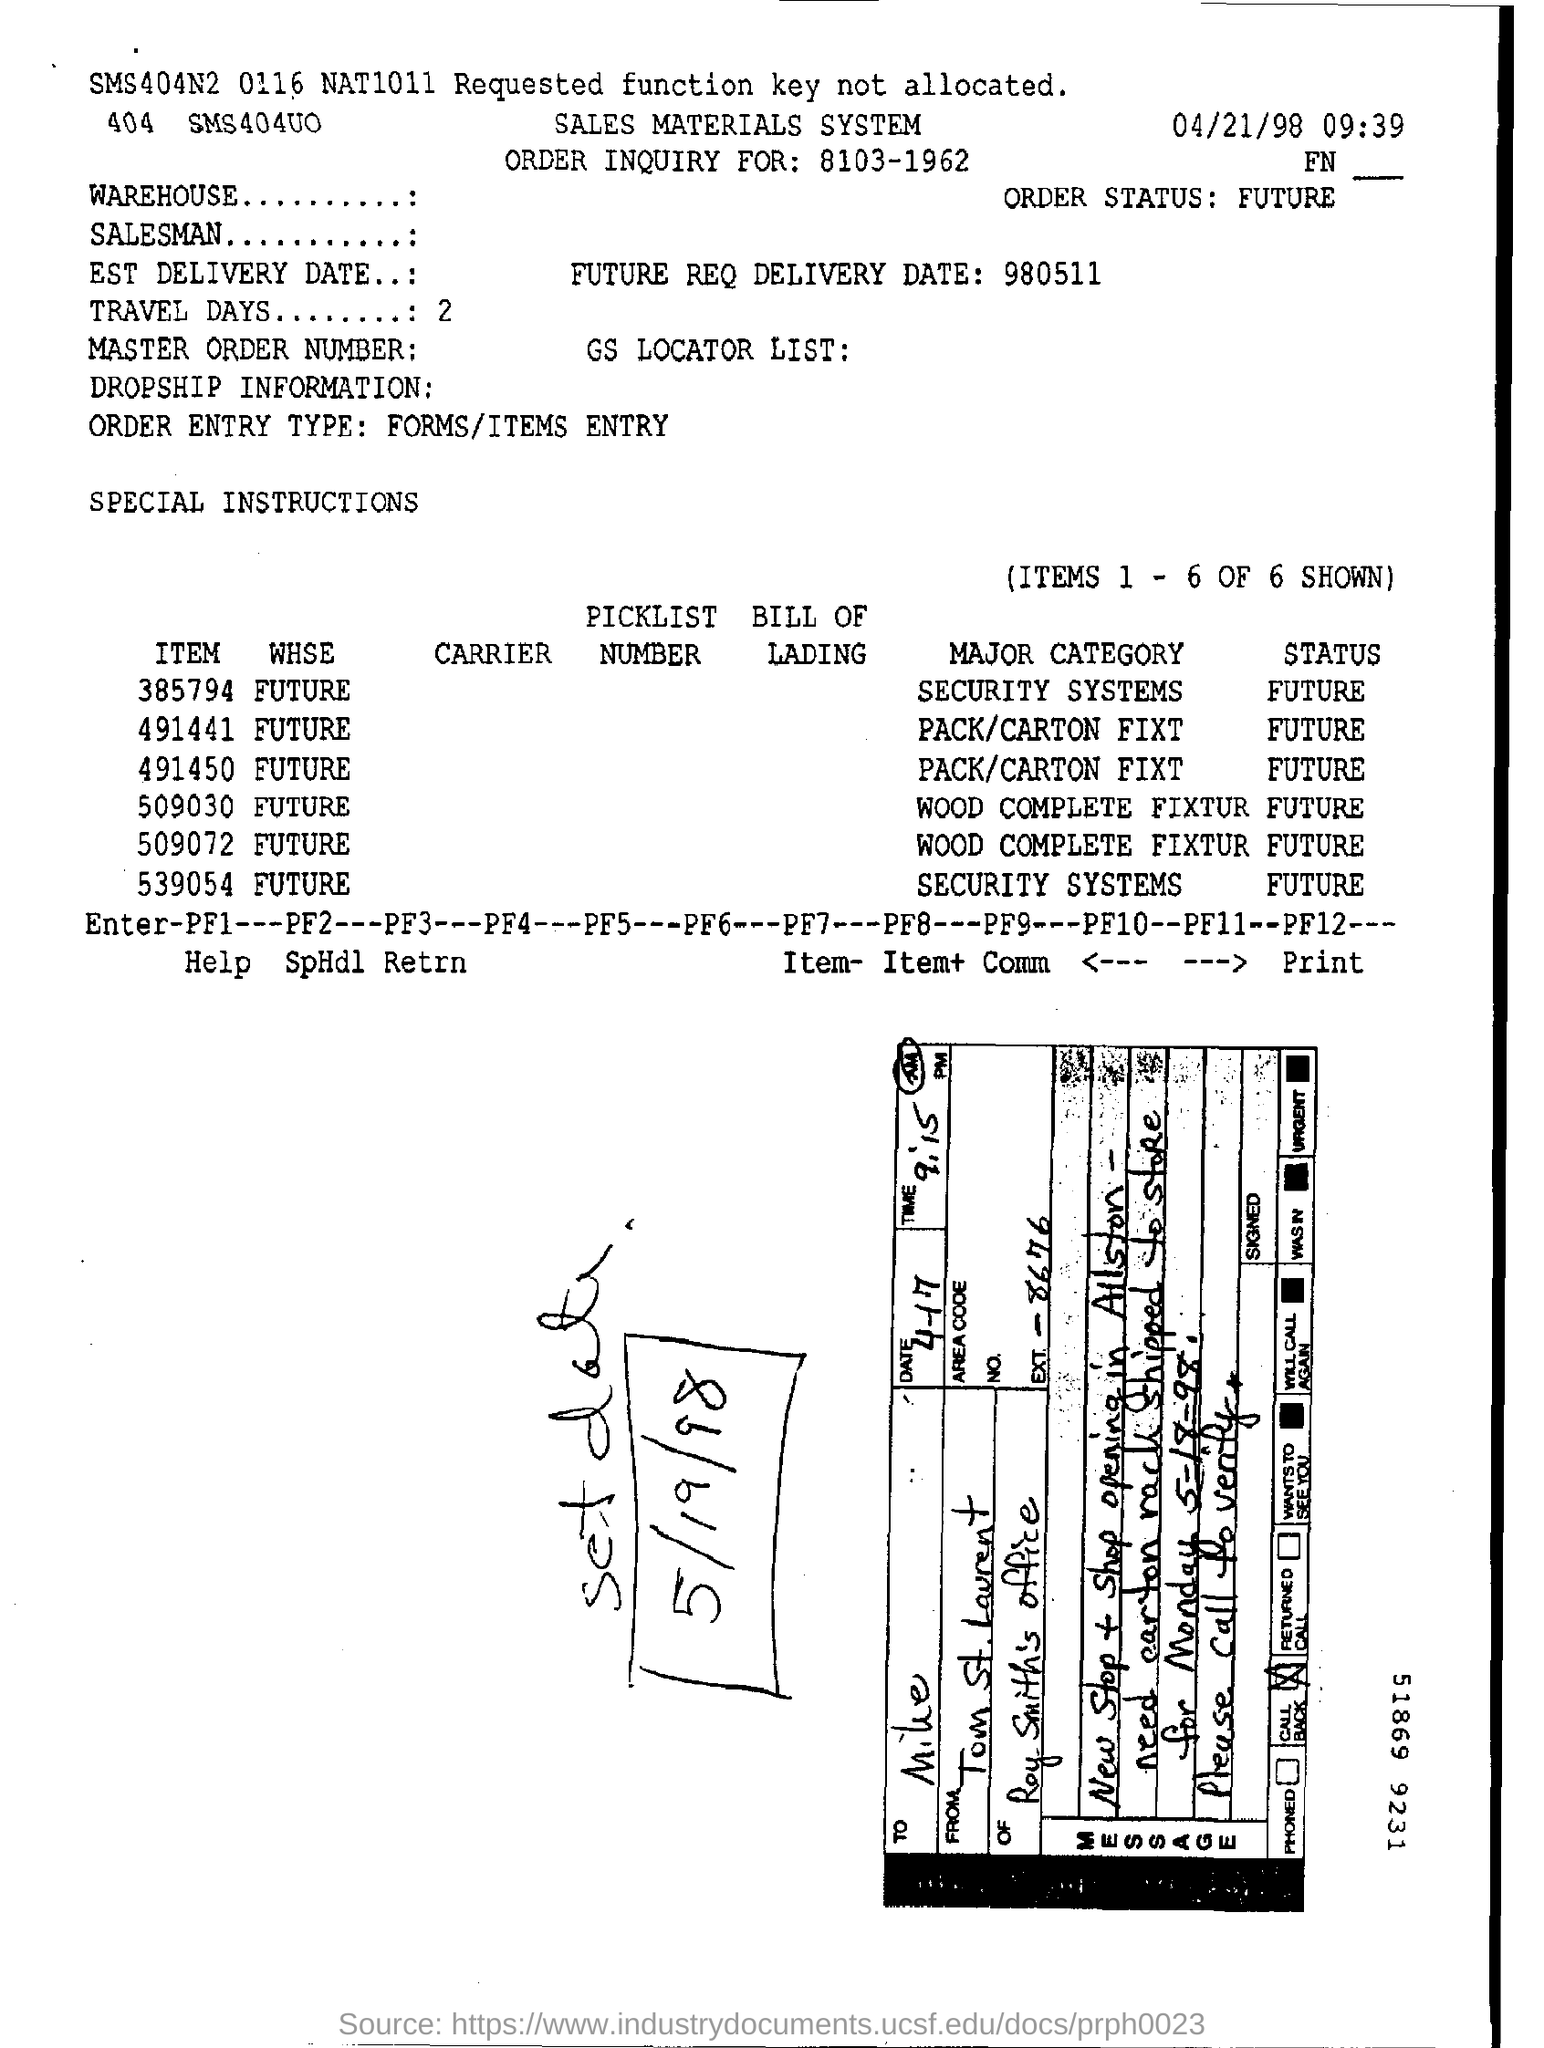What is the date given at the right top corner of the page?
Provide a succinct answer. 04/21/98. What is the time mentioned along with date at the right top corner of the page?
Ensure brevity in your answer.  09:39. What is the "ORDER INQUIRY FOR:" number mentioned?
Make the answer very short. 8103-1962. What is the ORDER STATUS"?
Your answer should be compact. Future. What is the FUTURE REQ DELIVERY DATE number given?
Your answer should be very brief. 980511. How many TRAVEL DAYS are given?
Your response must be concise. 2. What is the ORDER ENTRY TYPE?
Offer a terse response. FORMS/ITEMS ENTRY. What is the MAJOR CATEGORY of  ITEM number 385794?
Provide a succinct answer. Security systems. What is the MAJOR CATEGORY of ITEM number 491441?
Make the answer very short. PACK/CARTON FIXT. What is the MAJOR CATEGORY of ITEM number 509030?
Make the answer very short. Wood complete fixtur. What is the STATUS of ITEM number 509030?
Ensure brevity in your answer.  Future. 